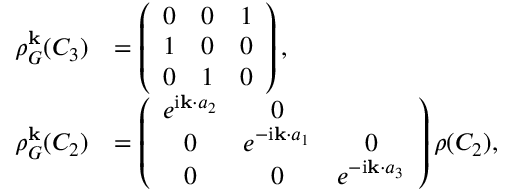Convert formula to latex. <formula><loc_0><loc_0><loc_500><loc_500>\begin{array} { r l } { \rho _ { G } ^ { k } ( C _ { 3 } ) } & { = \left ( \begin{array} { c c c } { 0 } & { 0 } & { 1 } \\ { 1 } & { 0 } & { 0 } \\ { 0 } & { 1 } & { 0 } \end{array} \right ) , } \\ { \rho _ { G } ^ { k } ( C _ { 2 } ) } & { = \left ( \begin{array} { c c c } { e ^ { i { k } \cdot { a } _ { 2 } } } & { 0 } \\ { 0 } & { e ^ { - i { k } \cdot { a } _ { 1 } } } & { 0 } \\ { 0 } & { 0 } & { e ^ { - i { k } \cdot { a } _ { 3 } } } \end{array} \right ) \rho ( C _ { 2 } ) , } \end{array}</formula> 